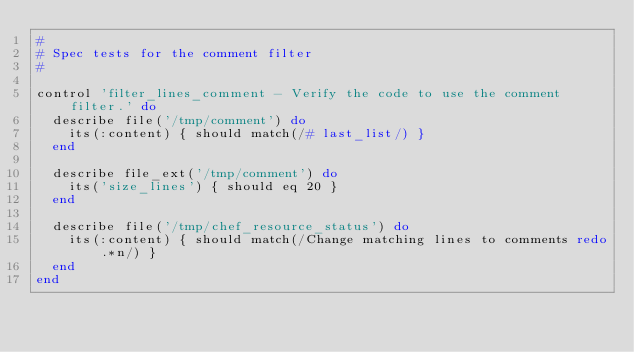Convert code to text. <code><loc_0><loc_0><loc_500><loc_500><_Ruby_>#
# Spec tests for the comment filter
#

control 'filter_lines_comment - Verify the code to use the comment filter.' do
  describe file('/tmp/comment') do
    its(:content) { should match(/# last_list/) }
  end

  describe file_ext('/tmp/comment') do
    its('size_lines') { should eq 20 }
  end

  describe file('/tmp/chef_resource_status') do
    its(:content) { should match(/Change matching lines to comments redo.*n/) }
  end
end
</code> 